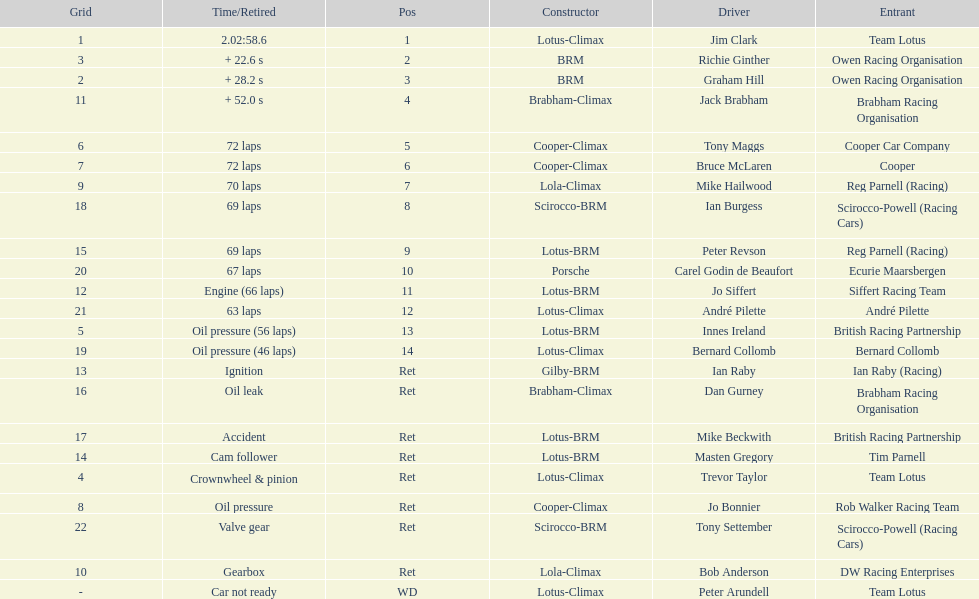What is the number of americans in the top 5? 1. 